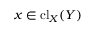<formula> <loc_0><loc_0><loc_500><loc_500>x \in { c l } _ { X } ( Y )</formula> 